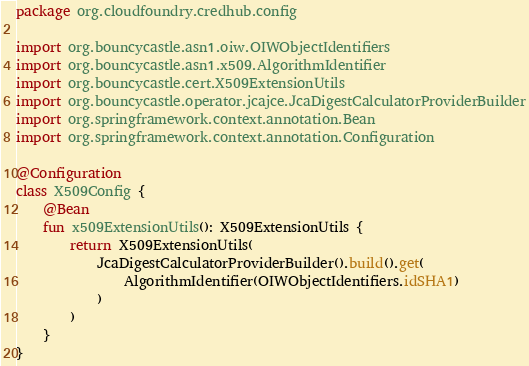<code> <loc_0><loc_0><loc_500><loc_500><_Kotlin_>package org.cloudfoundry.credhub.config

import org.bouncycastle.asn1.oiw.OIWObjectIdentifiers
import org.bouncycastle.asn1.x509.AlgorithmIdentifier
import org.bouncycastle.cert.X509ExtensionUtils
import org.bouncycastle.operator.jcajce.JcaDigestCalculatorProviderBuilder
import org.springframework.context.annotation.Bean
import org.springframework.context.annotation.Configuration

@Configuration
class X509Config {
    @Bean
    fun x509ExtensionUtils(): X509ExtensionUtils {
        return X509ExtensionUtils(
            JcaDigestCalculatorProviderBuilder().build().get(
                AlgorithmIdentifier(OIWObjectIdentifiers.idSHA1)
            )
        )
    }
}
</code> 